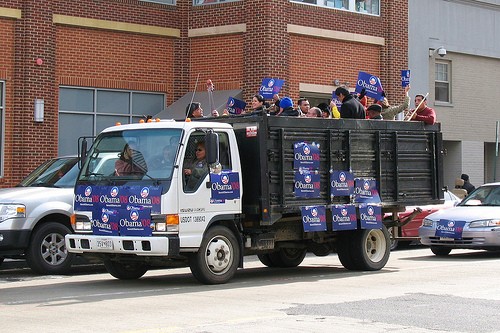Please provide a short description for this region: [0.38, 0.6, 0.78, 0.72]. The tires of the truck are visible. 